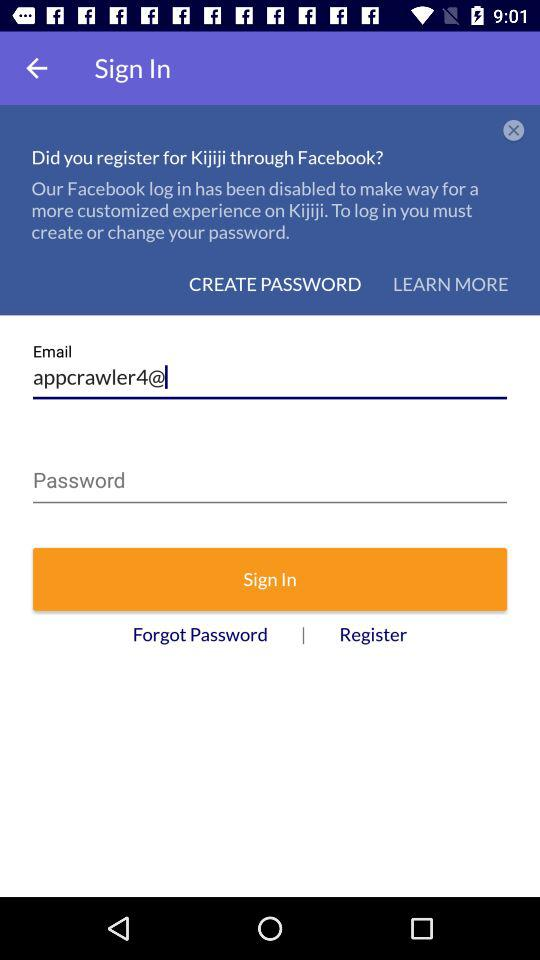What is the name of the application? The name of the application is "kijiji". 